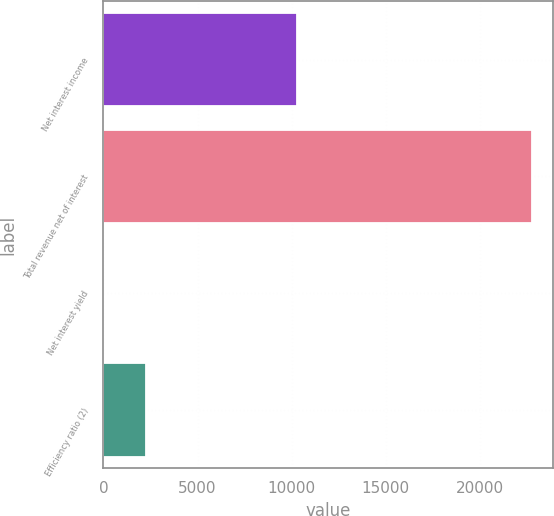<chart> <loc_0><loc_0><loc_500><loc_500><bar_chart><fcel>Net interest income<fcel>Total revenue net of interest<fcel>Net interest yield<fcel>Efficiency ratio (2)<nl><fcel>10286<fcel>22767<fcel>2.29<fcel>2278.76<nl></chart> 